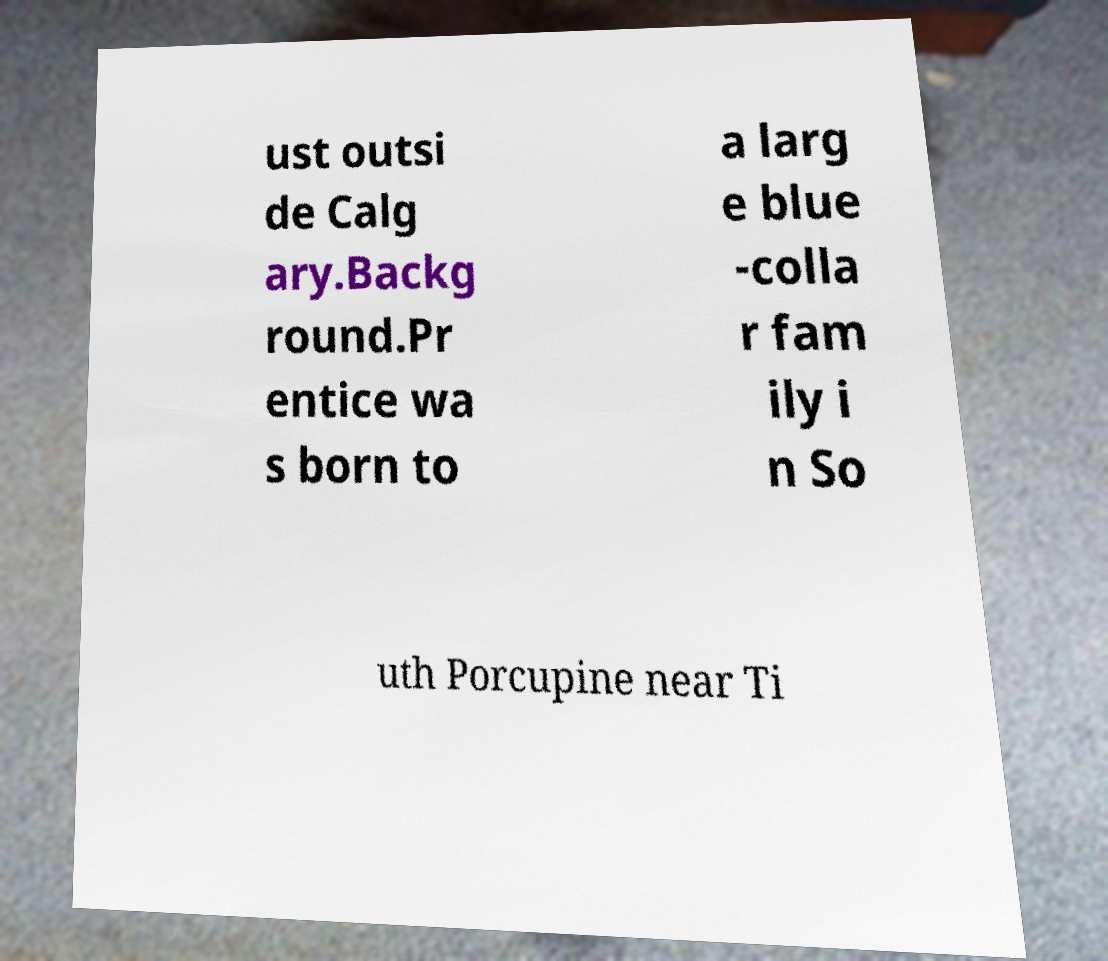There's text embedded in this image that I need extracted. Can you transcribe it verbatim? ust outsi de Calg ary.Backg round.Pr entice wa s born to a larg e blue -colla r fam ily i n So uth Porcupine near Ti 